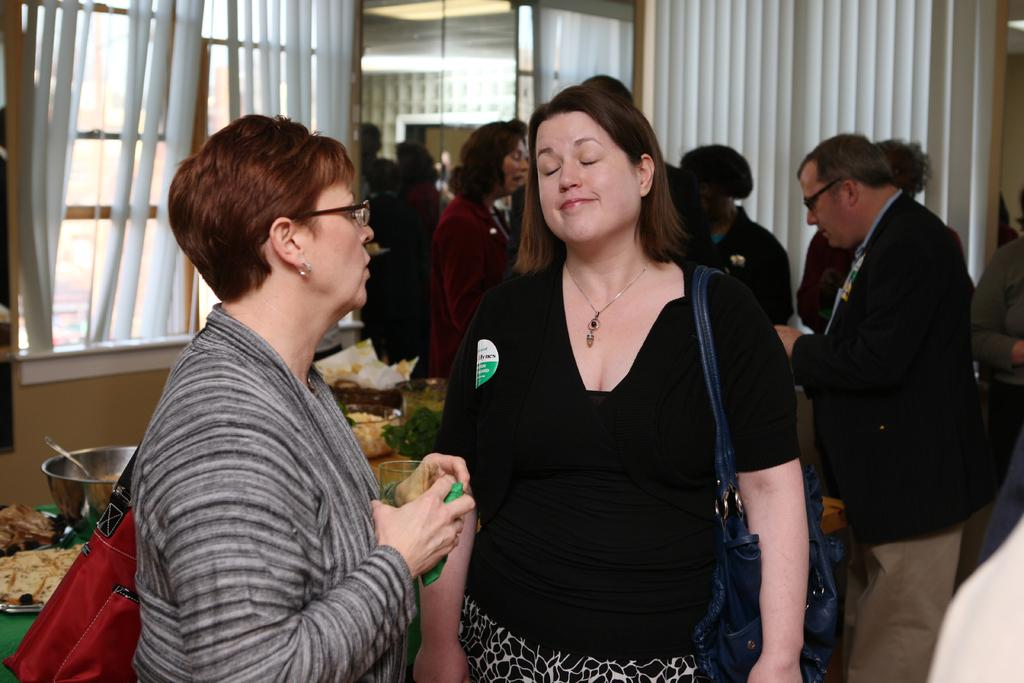What is happening in the image? There are people standing in the image. What are the people wearing? The people are wearing bags. What can be seen in the background of the image? There are curtains, windows, electric lights, and a table in the background of the image. What is on the table in the background? Food is present on the table. Can you see a baby sparking a selfie in the image? There is no baby or selfie present in the image. 